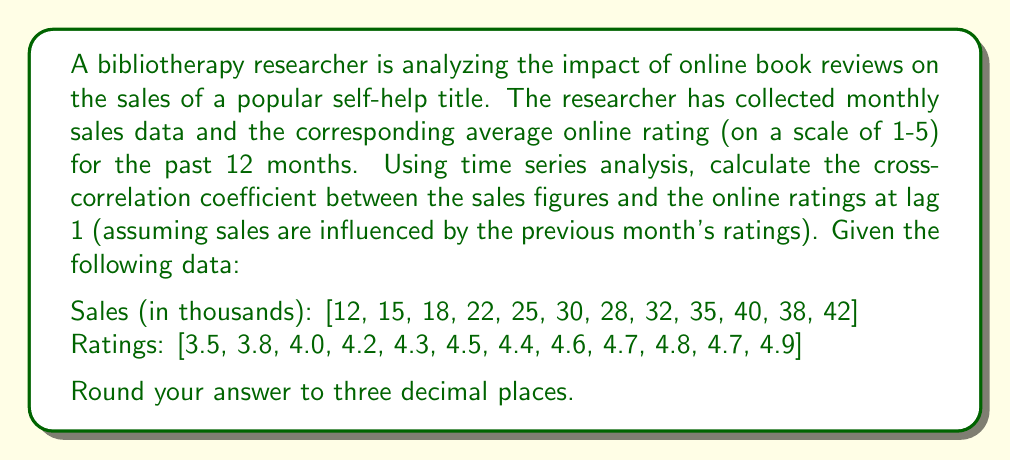What is the answer to this math problem? To calculate the cross-correlation coefficient at lag 1, we need to follow these steps:

1. Shift the ratings series by 1 lag (remove the last rating and prepend with the mean of ratings).
2. Calculate the means of both series.
3. Calculate the standard deviations of both series.
4. Compute the cross-covariance.
5. Divide the cross-covariance by the product of standard deviations.

Step 1: Shift ratings series
Original ratings: [3.5, 3.8, 4.0, 4.2, 4.3, 4.5, 4.4, 4.6, 4.7, 4.8, 4.7, 4.9]
Mean of ratings: 4.366667
Shifted ratings: [4.366667, 3.5, 3.8, 4.0, 4.2, 4.3, 4.5, 4.4, 4.6, 4.7, 4.8, 4.7]

Step 2: Calculate means
$\bar{x} = \frac{1}{n}\sum_{i=1}^n x_i = 28.0833$ (mean of sales)
$\bar{y} = \frac{1}{n}\sum_{i=1}^n y_i = 4.3222$ (mean of shifted ratings)

Step 3: Calculate standard deviations
$s_x = \sqrt{\frac{1}{n-1}\sum_{i=1}^n (x_i - \bar{x})^2} = 10.1743$
$s_y = \sqrt{\frac{1}{n-1}\sum_{i=1}^n (y_i - \bar{y})^2} = 0.3848$

Step 4: Compute cross-covariance
$\text{Cov}_{xy} = \frac{1}{n-1}\sum_{i=1}^n (x_i - \bar{x})(y_i - \bar{y}) = 1.6780$

Step 5: Calculate cross-correlation coefficient
$$r_{xy} = \frac{\text{Cov}_{xy}}{s_x s_y} = \frac{1.6780}{10.1743 \times 0.3848} = 0.4289$$

Rounding to three decimal places, we get 0.429.
Answer: 0.429 